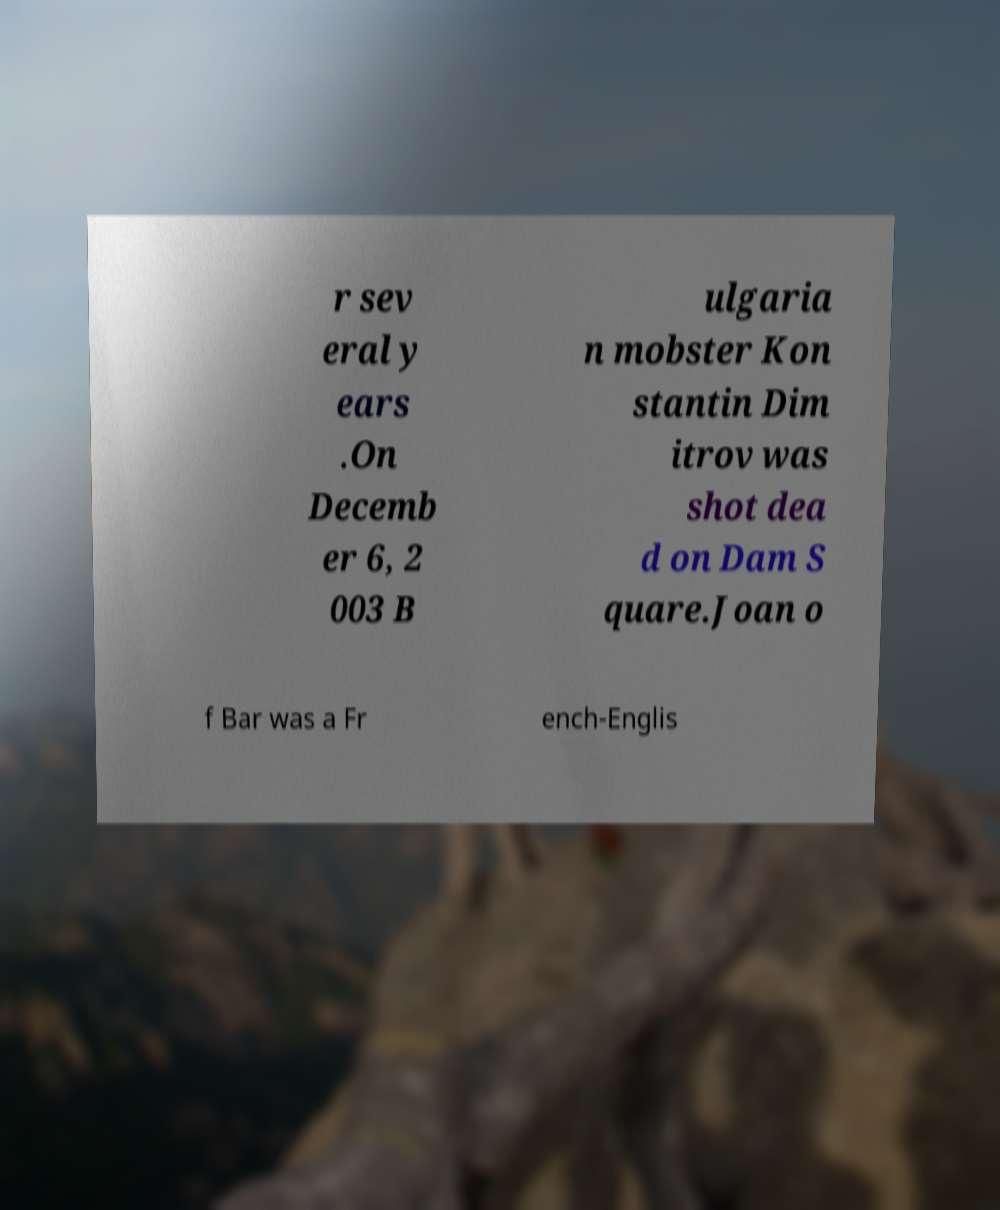Please identify and transcribe the text found in this image. r sev eral y ears .On Decemb er 6, 2 003 B ulgaria n mobster Kon stantin Dim itrov was shot dea d on Dam S quare.Joan o f Bar was a Fr ench-Englis 